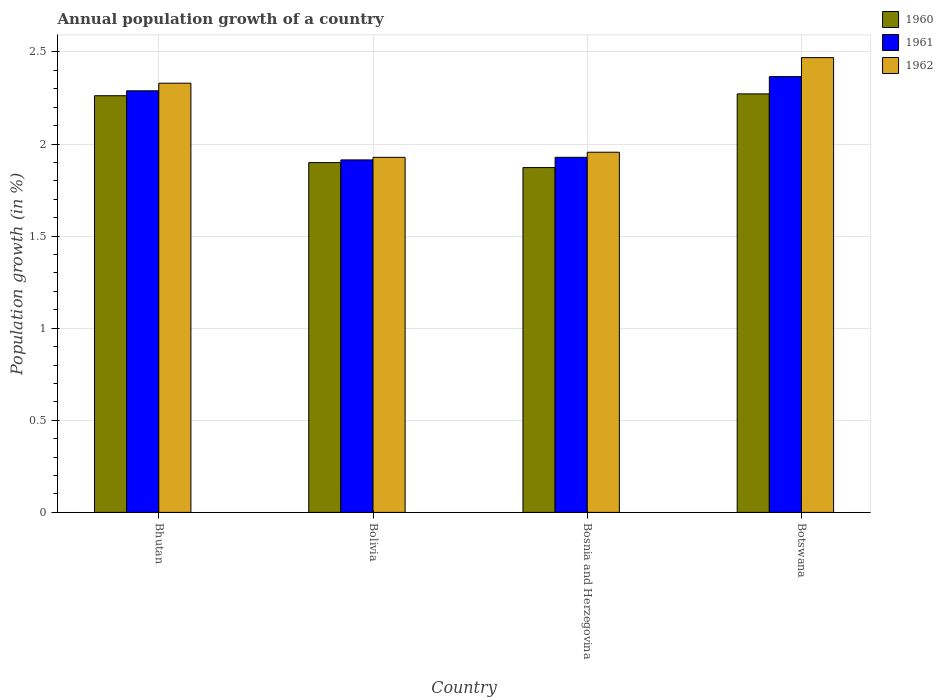How many different coloured bars are there?
Your answer should be compact. 3. How many groups of bars are there?
Provide a short and direct response. 4. Are the number of bars per tick equal to the number of legend labels?
Offer a terse response. Yes. How many bars are there on the 1st tick from the left?
Offer a very short reply. 3. How many bars are there on the 3rd tick from the right?
Make the answer very short. 3. What is the label of the 2nd group of bars from the left?
Provide a short and direct response. Bolivia. What is the annual population growth in 1962 in Bolivia?
Provide a succinct answer. 1.93. Across all countries, what is the maximum annual population growth in 1961?
Provide a succinct answer. 2.37. Across all countries, what is the minimum annual population growth in 1960?
Give a very brief answer. 1.87. In which country was the annual population growth in 1960 maximum?
Provide a succinct answer. Botswana. In which country was the annual population growth in 1960 minimum?
Offer a terse response. Bosnia and Herzegovina. What is the total annual population growth in 1960 in the graph?
Provide a short and direct response. 8.31. What is the difference between the annual population growth in 1962 in Bhutan and that in Bosnia and Herzegovina?
Give a very brief answer. 0.37. What is the difference between the annual population growth in 1962 in Bosnia and Herzegovina and the annual population growth in 1960 in Botswana?
Provide a short and direct response. -0.32. What is the average annual population growth in 1960 per country?
Offer a very short reply. 2.08. What is the difference between the annual population growth of/in 1961 and annual population growth of/in 1962 in Bosnia and Herzegovina?
Ensure brevity in your answer.  -0.03. What is the ratio of the annual population growth in 1960 in Bhutan to that in Botswana?
Keep it short and to the point. 1. What is the difference between the highest and the second highest annual population growth in 1962?
Offer a very short reply. -0.51. What is the difference between the highest and the lowest annual population growth in 1960?
Offer a very short reply. 0.4. What does the 1st bar from the left in Bosnia and Herzegovina represents?
Ensure brevity in your answer.  1960. What does the 3rd bar from the right in Botswana represents?
Give a very brief answer. 1960. Is it the case that in every country, the sum of the annual population growth in 1961 and annual population growth in 1962 is greater than the annual population growth in 1960?
Provide a short and direct response. Yes. How many bars are there?
Ensure brevity in your answer.  12. Are all the bars in the graph horizontal?
Provide a succinct answer. No. Does the graph contain grids?
Your response must be concise. Yes. Where does the legend appear in the graph?
Your answer should be compact. Top right. How many legend labels are there?
Offer a terse response. 3. How are the legend labels stacked?
Provide a succinct answer. Vertical. What is the title of the graph?
Your answer should be compact. Annual population growth of a country. What is the label or title of the Y-axis?
Provide a short and direct response. Population growth (in %). What is the Population growth (in %) of 1960 in Bhutan?
Keep it short and to the point. 2.26. What is the Population growth (in %) of 1961 in Bhutan?
Offer a terse response. 2.29. What is the Population growth (in %) of 1962 in Bhutan?
Keep it short and to the point. 2.33. What is the Population growth (in %) in 1960 in Bolivia?
Give a very brief answer. 1.9. What is the Population growth (in %) of 1961 in Bolivia?
Your answer should be compact. 1.91. What is the Population growth (in %) in 1962 in Bolivia?
Your answer should be compact. 1.93. What is the Population growth (in %) in 1960 in Bosnia and Herzegovina?
Offer a terse response. 1.87. What is the Population growth (in %) in 1961 in Bosnia and Herzegovina?
Keep it short and to the point. 1.93. What is the Population growth (in %) in 1962 in Bosnia and Herzegovina?
Offer a very short reply. 1.96. What is the Population growth (in %) in 1960 in Botswana?
Provide a short and direct response. 2.27. What is the Population growth (in %) in 1961 in Botswana?
Keep it short and to the point. 2.37. What is the Population growth (in %) of 1962 in Botswana?
Ensure brevity in your answer.  2.47. Across all countries, what is the maximum Population growth (in %) in 1960?
Provide a succinct answer. 2.27. Across all countries, what is the maximum Population growth (in %) in 1961?
Offer a terse response. 2.37. Across all countries, what is the maximum Population growth (in %) of 1962?
Ensure brevity in your answer.  2.47. Across all countries, what is the minimum Population growth (in %) of 1960?
Ensure brevity in your answer.  1.87. Across all countries, what is the minimum Population growth (in %) of 1961?
Offer a terse response. 1.91. Across all countries, what is the minimum Population growth (in %) in 1962?
Your response must be concise. 1.93. What is the total Population growth (in %) of 1960 in the graph?
Make the answer very short. 8.31. What is the total Population growth (in %) of 1961 in the graph?
Make the answer very short. 8.5. What is the total Population growth (in %) of 1962 in the graph?
Offer a very short reply. 8.68. What is the difference between the Population growth (in %) of 1960 in Bhutan and that in Bolivia?
Offer a very short reply. 0.36. What is the difference between the Population growth (in %) of 1961 in Bhutan and that in Bolivia?
Ensure brevity in your answer.  0.38. What is the difference between the Population growth (in %) in 1962 in Bhutan and that in Bolivia?
Ensure brevity in your answer.  0.4. What is the difference between the Population growth (in %) of 1960 in Bhutan and that in Bosnia and Herzegovina?
Provide a succinct answer. 0.39. What is the difference between the Population growth (in %) in 1961 in Bhutan and that in Bosnia and Herzegovina?
Your response must be concise. 0.36. What is the difference between the Population growth (in %) in 1962 in Bhutan and that in Bosnia and Herzegovina?
Your answer should be very brief. 0.37. What is the difference between the Population growth (in %) in 1960 in Bhutan and that in Botswana?
Offer a terse response. -0.01. What is the difference between the Population growth (in %) in 1961 in Bhutan and that in Botswana?
Make the answer very short. -0.08. What is the difference between the Population growth (in %) of 1962 in Bhutan and that in Botswana?
Offer a very short reply. -0.14. What is the difference between the Population growth (in %) of 1960 in Bolivia and that in Bosnia and Herzegovina?
Offer a terse response. 0.03. What is the difference between the Population growth (in %) in 1961 in Bolivia and that in Bosnia and Herzegovina?
Ensure brevity in your answer.  -0.01. What is the difference between the Population growth (in %) in 1962 in Bolivia and that in Bosnia and Herzegovina?
Ensure brevity in your answer.  -0.03. What is the difference between the Population growth (in %) in 1960 in Bolivia and that in Botswana?
Provide a succinct answer. -0.37. What is the difference between the Population growth (in %) in 1961 in Bolivia and that in Botswana?
Keep it short and to the point. -0.45. What is the difference between the Population growth (in %) of 1962 in Bolivia and that in Botswana?
Your response must be concise. -0.54. What is the difference between the Population growth (in %) of 1960 in Bosnia and Herzegovina and that in Botswana?
Your answer should be very brief. -0.4. What is the difference between the Population growth (in %) in 1961 in Bosnia and Herzegovina and that in Botswana?
Give a very brief answer. -0.44. What is the difference between the Population growth (in %) in 1962 in Bosnia and Herzegovina and that in Botswana?
Provide a succinct answer. -0.51. What is the difference between the Population growth (in %) in 1960 in Bhutan and the Population growth (in %) in 1961 in Bolivia?
Keep it short and to the point. 0.35. What is the difference between the Population growth (in %) of 1960 in Bhutan and the Population growth (in %) of 1962 in Bolivia?
Make the answer very short. 0.33. What is the difference between the Population growth (in %) of 1961 in Bhutan and the Population growth (in %) of 1962 in Bolivia?
Offer a terse response. 0.36. What is the difference between the Population growth (in %) of 1960 in Bhutan and the Population growth (in %) of 1961 in Bosnia and Herzegovina?
Make the answer very short. 0.33. What is the difference between the Population growth (in %) in 1960 in Bhutan and the Population growth (in %) in 1962 in Bosnia and Herzegovina?
Keep it short and to the point. 0.31. What is the difference between the Population growth (in %) of 1961 in Bhutan and the Population growth (in %) of 1962 in Bosnia and Herzegovina?
Your response must be concise. 0.33. What is the difference between the Population growth (in %) of 1960 in Bhutan and the Population growth (in %) of 1961 in Botswana?
Keep it short and to the point. -0.1. What is the difference between the Population growth (in %) in 1960 in Bhutan and the Population growth (in %) in 1962 in Botswana?
Provide a short and direct response. -0.21. What is the difference between the Population growth (in %) in 1961 in Bhutan and the Population growth (in %) in 1962 in Botswana?
Your answer should be very brief. -0.18. What is the difference between the Population growth (in %) in 1960 in Bolivia and the Population growth (in %) in 1961 in Bosnia and Herzegovina?
Make the answer very short. -0.03. What is the difference between the Population growth (in %) of 1960 in Bolivia and the Population growth (in %) of 1962 in Bosnia and Herzegovina?
Provide a succinct answer. -0.06. What is the difference between the Population growth (in %) in 1961 in Bolivia and the Population growth (in %) in 1962 in Bosnia and Herzegovina?
Ensure brevity in your answer.  -0.04. What is the difference between the Population growth (in %) of 1960 in Bolivia and the Population growth (in %) of 1961 in Botswana?
Provide a short and direct response. -0.47. What is the difference between the Population growth (in %) of 1960 in Bolivia and the Population growth (in %) of 1962 in Botswana?
Provide a succinct answer. -0.57. What is the difference between the Population growth (in %) in 1961 in Bolivia and the Population growth (in %) in 1962 in Botswana?
Your answer should be compact. -0.56. What is the difference between the Population growth (in %) of 1960 in Bosnia and Herzegovina and the Population growth (in %) of 1961 in Botswana?
Ensure brevity in your answer.  -0.49. What is the difference between the Population growth (in %) of 1960 in Bosnia and Herzegovina and the Population growth (in %) of 1962 in Botswana?
Make the answer very short. -0.6. What is the difference between the Population growth (in %) of 1961 in Bosnia and Herzegovina and the Population growth (in %) of 1962 in Botswana?
Offer a very short reply. -0.54. What is the average Population growth (in %) in 1960 per country?
Offer a very short reply. 2.08. What is the average Population growth (in %) of 1961 per country?
Ensure brevity in your answer.  2.12. What is the average Population growth (in %) of 1962 per country?
Give a very brief answer. 2.17. What is the difference between the Population growth (in %) in 1960 and Population growth (in %) in 1961 in Bhutan?
Give a very brief answer. -0.03. What is the difference between the Population growth (in %) in 1960 and Population growth (in %) in 1962 in Bhutan?
Offer a terse response. -0.07. What is the difference between the Population growth (in %) in 1961 and Population growth (in %) in 1962 in Bhutan?
Offer a terse response. -0.04. What is the difference between the Population growth (in %) of 1960 and Population growth (in %) of 1961 in Bolivia?
Your answer should be compact. -0.01. What is the difference between the Population growth (in %) in 1960 and Population growth (in %) in 1962 in Bolivia?
Provide a succinct answer. -0.03. What is the difference between the Population growth (in %) in 1961 and Population growth (in %) in 1962 in Bolivia?
Provide a succinct answer. -0.01. What is the difference between the Population growth (in %) of 1960 and Population growth (in %) of 1961 in Bosnia and Herzegovina?
Make the answer very short. -0.06. What is the difference between the Population growth (in %) in 1960 and Population growth (in %) in 1962 in Bosnia and Herzegovina?
Your answer should be very brief. -0.08. What is the difference between the Population growth (in %) of 1961 and Population growth (in %) of 1962 in Bosnia and Herzegovina?
Give a very brief answer. -0.03. What is the difference between the Population growth (in %) of 1960 and Population growth (in %) of 1961 in Botswana?
Your response must be concise. -0.09. What is the difference between the Population growth (in %) in 1960 and Population growth (in %) in 1962 in Botswana?
Provide a succinct answer. -0.2. What is the difference between the Population growth (in %) in 1961 and Population growth (in %) in 1962 in Botswana?
Keep it short and to the point. -0.1. What is the ratio of the Population growth (in %) of 1960 in Bhutan to that in Bolivia?
Provide a succinct answer. 1.19. What is the ratio of the Population growth (in %) in 1961 in Bhutan to that in Bolivia?
Ensure brevity in your answer.  1.2. What is the ratio of the Population growth (in %) in 1962 in Bhutan to that in Bolivia?
Your response must be concise. 1.21. What is the ratio of the Population growth (in %) of 1960 in Bhutan to that in Bosnia and Herzegovina?
Keep it short and to the point. 1.21. What is the ratio of the Population growth (in %) in 1961 in Bhutan to that in Bosnia and Herzegovina?
Keep it short and to the point. 1.19. What is the ratio of the Population growth (in %) of 1962 in Bhutan to that in Bosnia and Herzegovina?
Offer a very short reply. 1.19. What is the ratio of the Population growth (in %) in 1960 in Bhutan to that in Botswana?
Give a very brief answer. 1. What is the ratio of the Population growth (in %) in 1961 in Bhutan to that in Botswana?
Offer a very short reply. 0.97. What is the ratio of the Population growth (in %) of 1962 in Bhutan to that in Botswana?
Your answer should be compact. 0.94. What is the ratio of the Population growth (in %) of 1960 in Bolivia to that in Bosnia and Herzegovina?
Ensure brevity in your answer.  1.01. What is the ratio of the Population growth (in %) in 1961 in Bolivia to that in Bosnia and Herzegovina?
Your response must be concise. 0.99. What is the ratio of the Population growth (in %) in 1962 in Bolivia to that in Bosnia and Herzegovina?
Your response must be concise. 0.99. What is the ratio of the Population growth (in %) of 1960 in Bolivia to that in Botswana?
Give a very brief answer. 0.84. What is the ratio of the Population growth (in %) of 1961 in Bolivia to that in Botswana?
Your answer should be compact. 0.81. What is the ratio of the Population growth (in %) of 1962 in Bolivia to that in Botswana?
Provide a succinct answer. 0.78. What is the ratio of the Population growth (in %) in 1960 in Bosnia and Herzegovina to that in Botswana?
Keep it short and to the point. 0.82. What is the ratio of the Population growth (in %) of 1961 in Bosnia and Herzegovina to that in Botswana?
Provide a short and direct response. 0.81. What is the ratio of the Population growth (in %) of 1962 in Bosnia and Herzegovina to that in Botswana?
Keep it short and to the point. 0.79. What is the difference between the highest and the second highest Population growth (in %) in 1960?
Your response must be concise. 0.01. What is the difference between the highest and the second highest Population growth (in %) in 1961?
Keep it short and to the point. 0.08. What is the difference between the highest and the second highest Population growth (in %) of 1962?
Make the answer very short. 0.14. What is the difference between the highest and the lowest Population growth (in %) in 1960?
Provide a short and direct response. 0.4. What is the difference between the highest and the lowest Population growth (in %) of 1961?
Your answer should be very brief. 0.45. What is the difference between the highest and the lowest Population growth (in %) in 1962?
Make the answer very short. 0.54. 